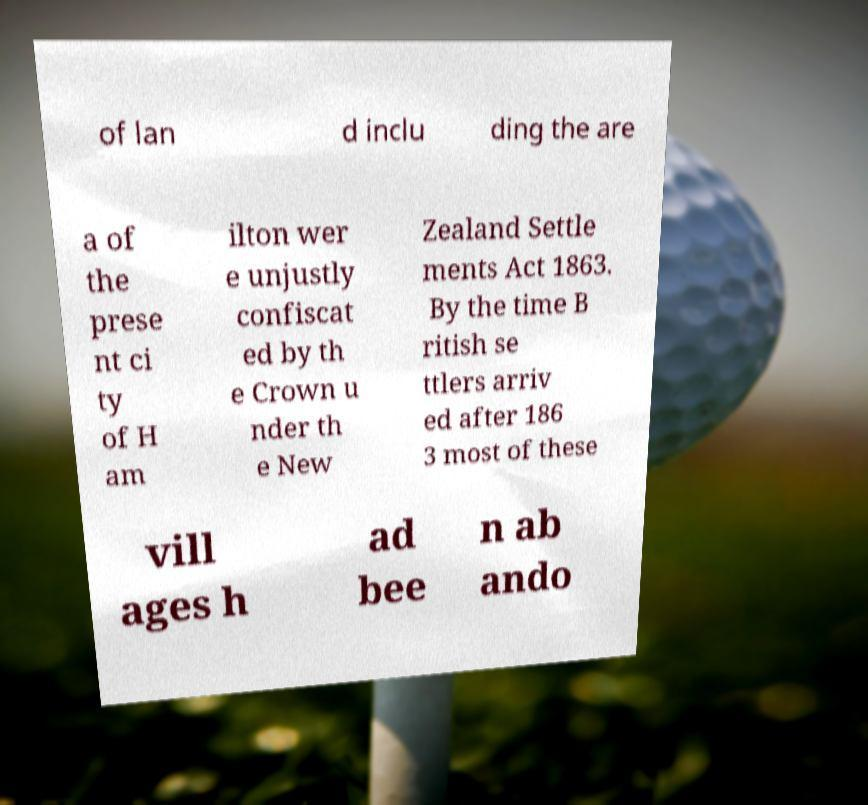There's text embedded in this image that I need extracted. Can you transcribe it verbatim? of lan d inclu ding the are a of the prese nt ci ty of H am ilton wer e unjustly confiscat ed by th e Crown u nder th e New Zealand Settle ments Act 1863. By the time B ritish se ttlers arriv ed after 186 3 most of these vill ages h ad bee n ab ando 